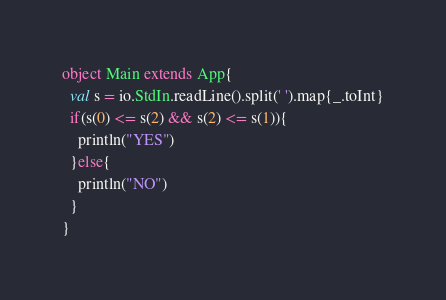Convert code to text. <code><loc_0><loc_0><loc_500><loc_500><_Scala_>object Main extends App{
  val s = io.StdIn.readLine().split(' ').map{_.toInt}
  if(s(0) <= s(2) && s(2) <= s(1)){
    println("YES")
  }else{
    println("NO")
  }
}
</code> 